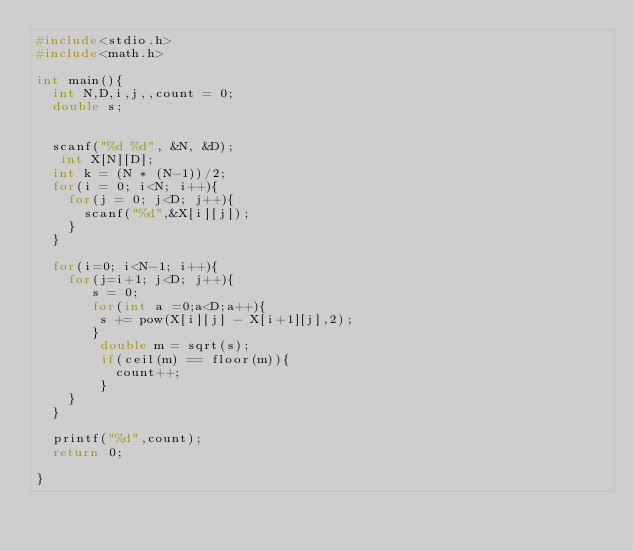Convert code to text. <code><loc_0><loc_0><loc_500><loc_500><_C_>#include<stdio.h>
#include<math.h>

int main(){
  int N,D,i,j,,count = 0;
  double s;

  
  scanf("%d %d", &N, &D);
   int X[N][D];
  int k = (N * (N-1))/2;
  for(i = 0; i<N; i++){
    for(j = 0; j<D; j++){
      scanf("%d",&X[i][j]);
    }
  }

  for(i=0; i<N-1; i++){
    for(j=i+1; j<D; j++){
       s = 0;
       for(int a =0;a<D;a++){
        s += pow(X[i][j] - X[i+1][j],2);
       }
        double m = sqrt(s);
        if(ceil(m) == floor(m)){
          count++;
        }
    }
  }
  
  printf("%d",count);
  return 0;

}</code> 